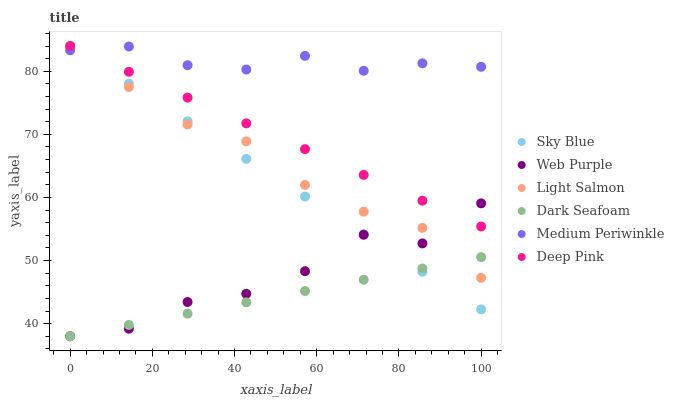Does Dark Seafoam have the minimum area under the curve?
Answer yes or no. Yes. Does Medium Periwinkle have the maximum area under the curve?
Answer yes or no. Yes. Does Deep Pink have the minimum area under the curve?
Answer yes or no. No. Does Deep Pink have the maximum area under the curve?
Answer yes or no. No. Is Dark Seafoam the smoothest?
Answer yes or no. Yes. Is Web Purple the roughest?
Answer yes or no. Yes. Is Deep Pink the smoothest?
Answer yes or no. No. Is Deep Pink the roughest?
Answer yes or no. No. Does Dark Seafoam have the lowest value?
Answer yes or no. Yes. Does Deep Pink have the lowest value?
Answer yes or no. No. Does Sky Blue have the highest value?
Answer yes or no. Yes. Does Medium Periwinkle have the highest value?
Answer yes or no. No. Is Dark Seafoam less than Medium Periwinkle?
Answer yes or no. Yes. Is Medium Periwinkle greater than Web Purple?
Answer yes or no. Yes. Does Deep Pink intersect Sky Blue?
Answer yes or no. Yes. Is Deep Pink less than Sky Blue?
Answer yes or no. No. Is Deep Pink greater than Sky Blue?
Answer yes or no. No. Does Dark Seafoam intersect Medium Periwinkle?
Answer yes or no. No. 